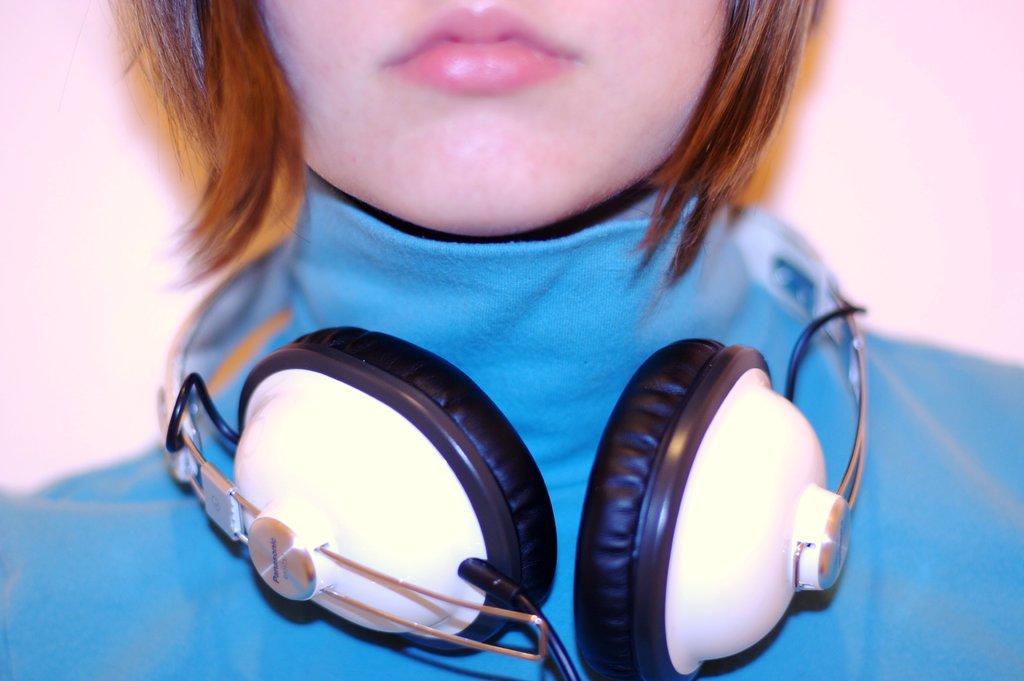Please provide a concise description of this image. In this we can observe a woman wearing blue color dress and headphones in her neck. The background is in pink color. 